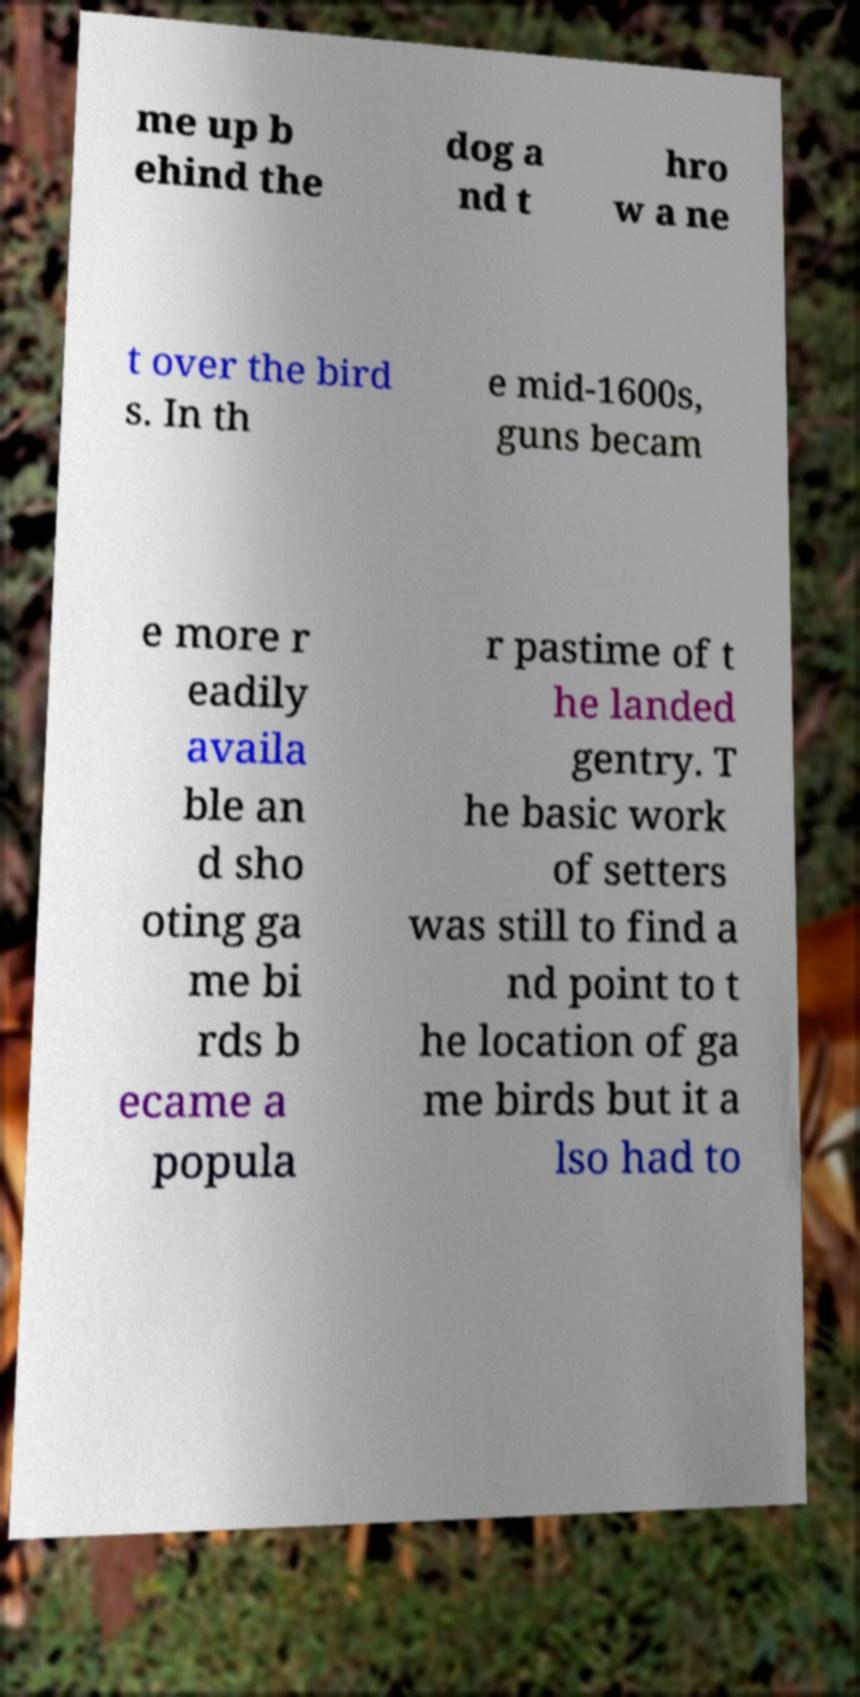What messages or text are displayed in this image? I need them in a readable, typed format. me up b ehind the dog a nd t hro w a ne t over the bird s. In th e mid-1600s, guns becam e more r eadily availa ble an d sho oting ga me bi rds b ecame a popula r pastime of t he landed gentry. T he basic work of setters was still to find a nd point to t he location of ga me birds but it a lso had to 